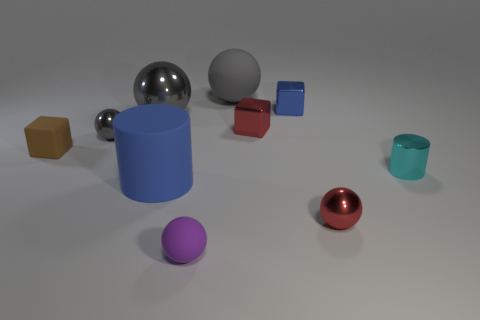How many gray balls must be subtracted to get 1 gray balls? 2 Subtract all red cylinders. How many gray spheres are left? 3 Subtract all purple balls. How many balls are left? 4 Subtract 1 cubes. How many cubes are left? 2 Subtract all red spheres. How many spheres are left? 4 Subtract all cubes. How many objects are left? 7 Add 1 tiny brown rubber things. How many tiny brown rubber things exist? 2 Subtract 0 cyan balls. How many objects are left? 10 Subtract all brown cylinders. Subtract all yellow spheres. How many cylinders are left? 2 Subtract all spheres. Subtract all blue blocks. How many objects are left? 4 